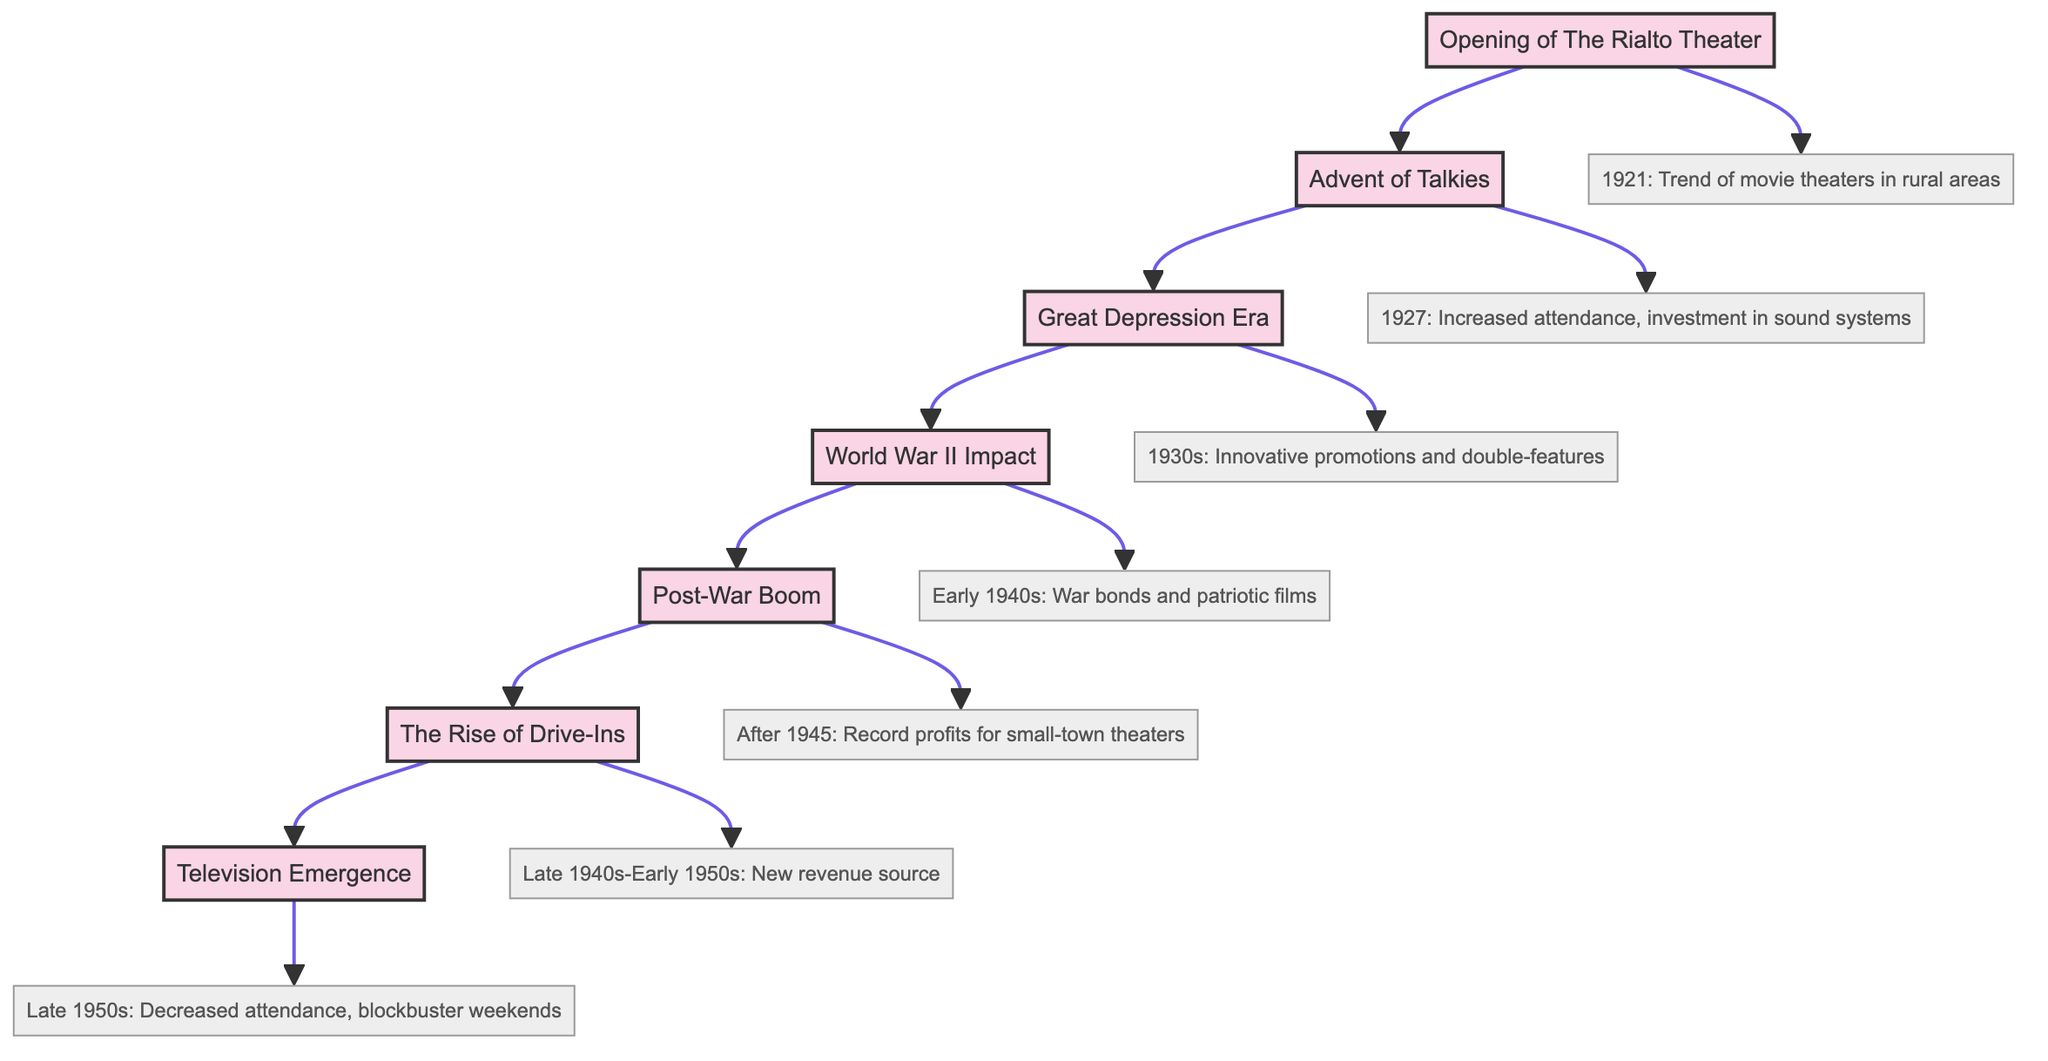What year did The Rialto Theater open? The diagram indicates that The Rialto Theater opened in 1921. This information is directly stated in the description connected to the milestone node for The Rialto Theater.
Answer: 1921 What influenced attendance in 1927? The increased attendance in 1927 was due to the "Advent of Talkies," as indicated in the diagram. The connection from the milestone node to its description node shows this relationship explicitly.
Answer: Talkies What major economic event affected theaters in the 1930s? The Great Depression Era is the major economic event noted in the diagram that affected small-town theaters. This is clearly marked as a milestone with a specific time frame and impact.
Answer: Great Depression How did small-town theaters maintain stability during World War II? The diagram states that theaters maintained financial stability through "war bonds and patriotic films." This is linked directly to the World War II Impact milestone showing the adaptive strategies used at that time.
Answer: War bonds What was a new revenue source introduced in the late 1940s? The Rise of Drive-Ins was the new revenue source introduced in the late 1940s. This information is found in the milestone node linked to its description node, clearly outlining the emergence of drive-in theaters.
Answer: Drive-Ins How did attendance trends change in the late 1950s? The diagram indicates that there was a decrease in attendance during the late 1950s due to the emergence of television. This observation is derived from the information linked to the Television Emergence milestone.
Answer: Decrease What link connects the opening of The Rialto Theater and the Advent of Talkies? The link between The Rialto Theater and the Advent of Talkies shows a chronological progression of events further establishing the relationship between the milestones. This is directly observable as a flow in the diagram connecting the two nodes.
Answer: A direct link How many key financial milestones are shown in the diagram? The diagram illustrates a total of seven key financial milestones. This can be counted by examining the number of milestone nodes present within the flowchart structure.
Answer: Seven What strategic shifts did small-town theaters adopt after 1945? The strategic shift mentioned post-1945 highlights "increased moviegoing," with a resultant "record profits." These details are clearly outlined in the description linked to the Post-War Boom milestone.
Answer: Increased moviegoing 